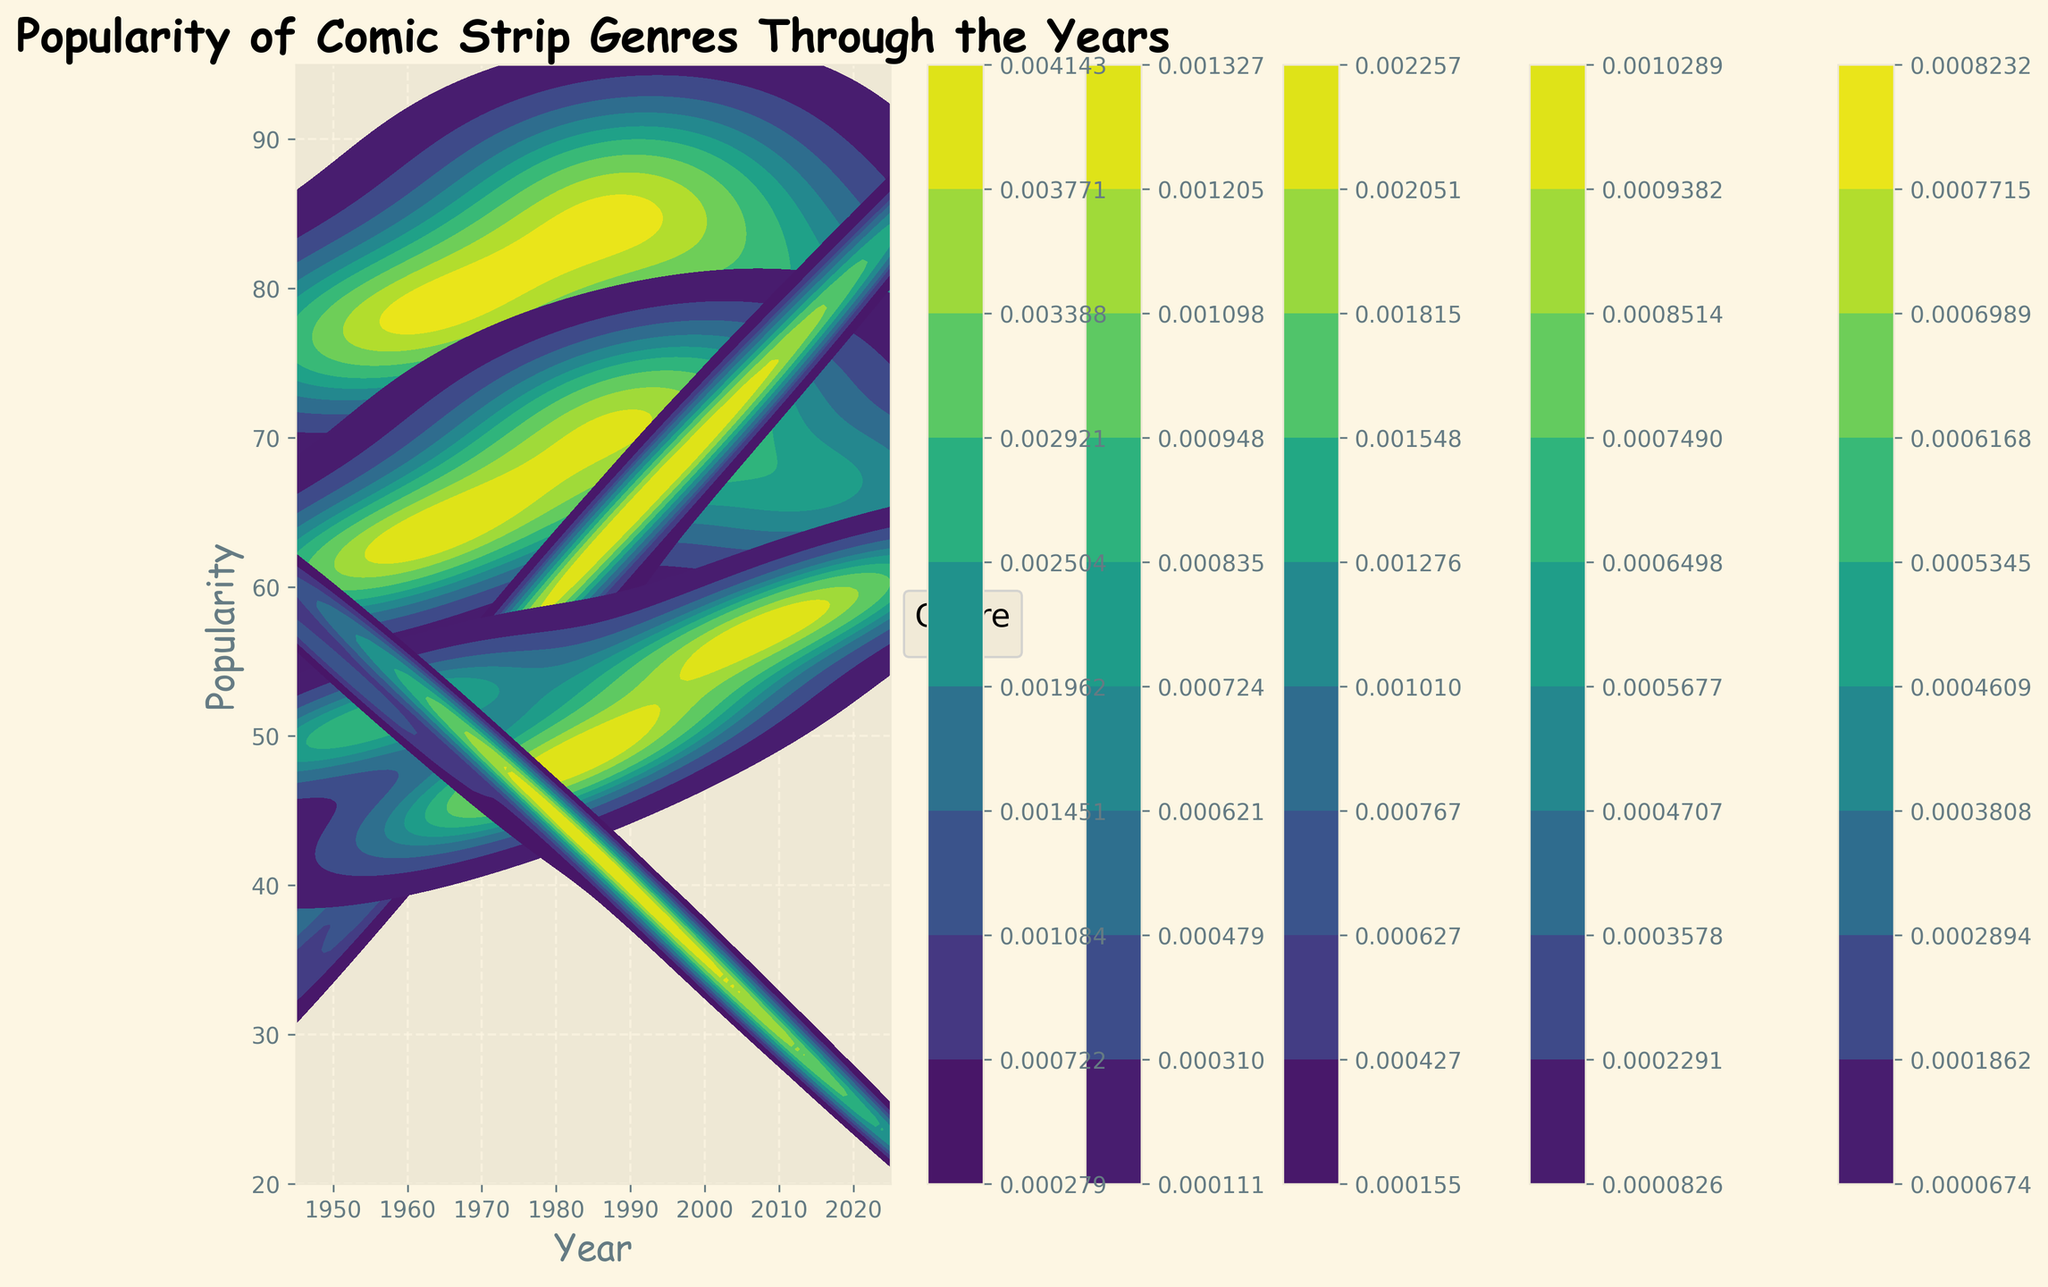What is the title of the figure? The title is typically at the top center of the plot. It should be in bold and larger font size compared to other text.
Answer: Popularity of Comic Strip Genres Through the Years What are the labels on the x-axis and y-axis? The x-axis label is usually at the bottom of the plot, and the y-axis label is on the left side. Both should be clearly visible.
Answer: Year, Popularity Which genre has the highest popularity in the year 2020? To find this, locate the year 2020 on the x-axis and see which genre's distribution peaks highest on the y-axis for that year.
Answer: Science Fiction How did the popularity of Adventure comics change from 1950 to 2020? Compare the popularity values for Adventure comics at the years 1950 and 2020 by looking at the height of the peak for those years.
Answer: Increased Which comic genre saw a decline in popularity from 1990 to 2020? Compare the peak popularity values of different genres between 1990 and 2020 to see which genre's popularity decreased.
Answer: Wartime What is the trend of the popularity of Humor comics from 1950 to 2020? Plot the data points for Humor comics across these years and observe whether the popularity is increasing, decreasing, or stable.
Answer: Decreasing Around which year did Science Fiction comics' popularity surpass Romance comics? Look at the point where the peaks of Science Fiction distributions start to be higher than those of Romance comics.
Answer: 2000 Between which decades does the largest increase in popularity for Science Fiction occur? Compare the peaks of Science Fiction distributions between each adjacent decade to find the largest increase.
Answer: 2000-2010 Which genre maintained relatively stable popularity throughout the years? Look for the genre whose distributions have peaks that do not change drastically across the years.
Answer: Humor Were there any genres that had a popularity peak around the 1980s? Observe the distribution curves for each genre and see if any peaks occur close to the 1980s.
Answer: Yes, Humor and Adventure 